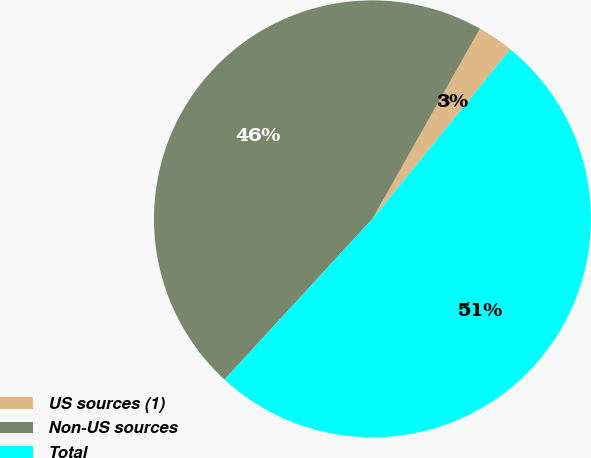Convert chart. <chart><loc_0><loc_0><loc_500><loc_500><pie_chart><fcel>US sources (1)<fcel>Non-US sources<fcel>Total<nl><fcel>2.67%<fcel>46.35%<fcel>50.98%<nl></chart> 